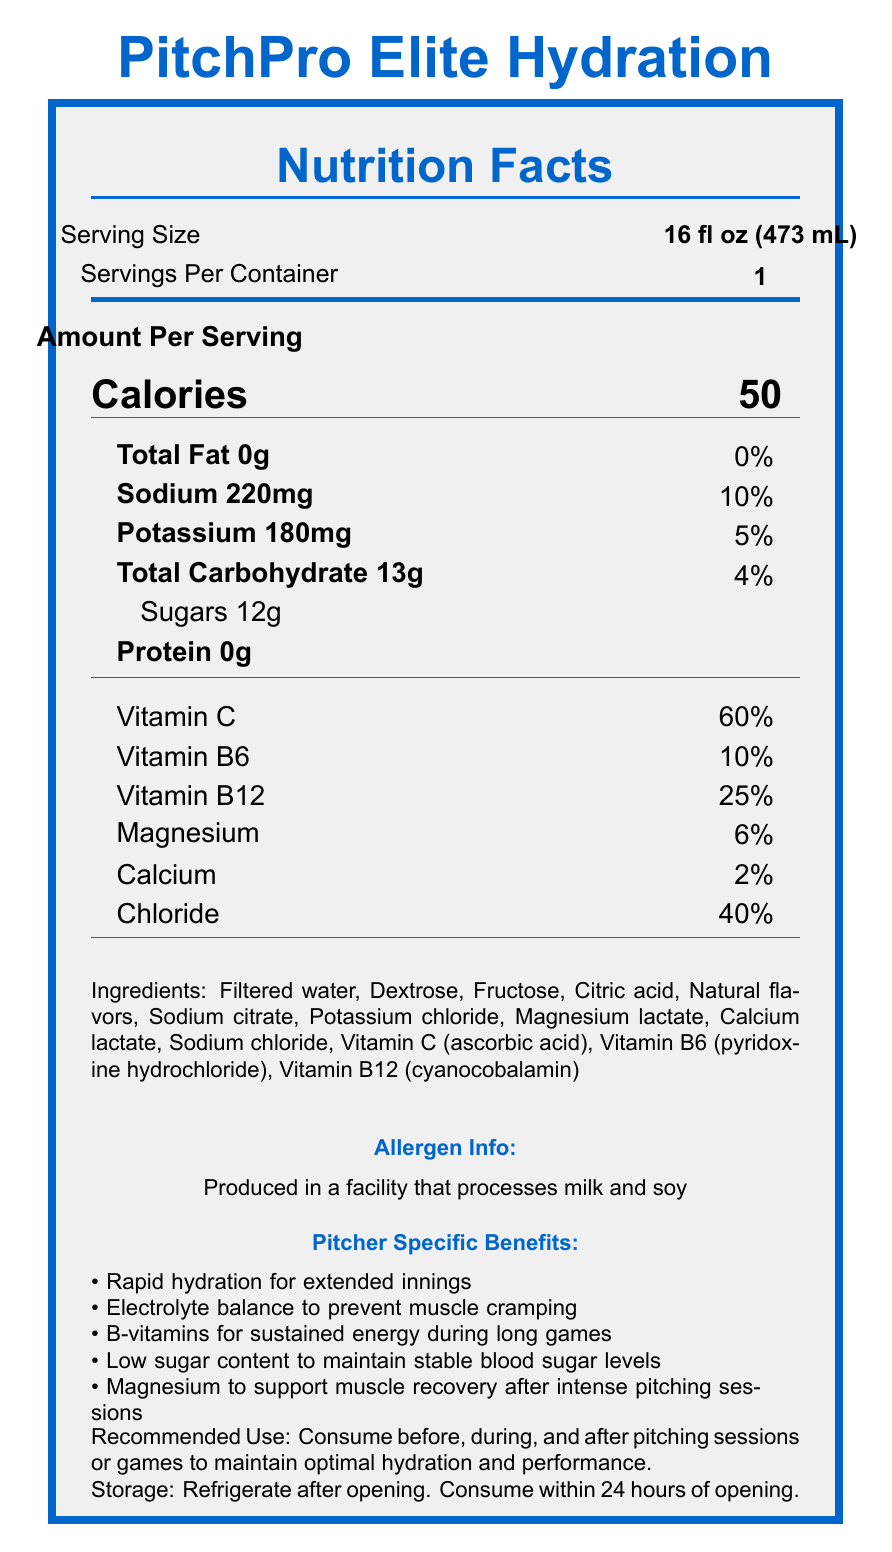what is the serving size of PitchPro Elite Hydration? The serving size is clearly mentioned under the nutrition facts header.
Answer: 16 fl oz (473 mL) how many calories are in one serving of PitchPro Elite Hydration? The number of calories per serving is displayed prominently under the "Amount Per Serving" section.
Answer: 50 how much sodium is in one serving? The sodium content is listed under the first few nutrients in the nutrition facts.
Answer: 220 mg how much potassium is in one serving? The potassium content is listed right after the sodium content in the nutrition facts.
Answer: 180 mg what vitamins are included and how much of each? The vitamins and their respective percentages are listed below the main nutrient section in the nutrition facts.
Answer: Vitamin C 60%, Vitamin B6 10%, Vitamin B12 25% What are the main ingredients in PitchPro Elite Hydration? A. Filtered water, Dextrose, Citric acid B. Filtered water, Dextrose, Fructose C. Filtered water, Sodium citrate, Potassium chloride D. Filtered water, Fructose, Vitamin C The initial ingredients listed include Filtered water, Dextrose, and Fructose.
Answer: B. Filtered water, Dextrose, Fructose Which of the following benefits is not explicitly stated for pitchers consuming this drink? 1. Improved batting performance 2. Electrolyte balance to prevent muscle cramping 3. Rapid hydration for extended innings 4. Magnesium to support muscle recovery The pitcher-specific benefits are listed and "Improved batting performance" is not one of them.
Answer: 1. Improved batting performance Does PitchPro Elite Hydration have any fat content? The nutrition facts clearly state that the total fat content is 0g.
Answer: No Is this product produced in a facility that processes any allergens? It is noted in the allergen info section that the product is produced in a facility that processes milk and soy.
Answer: Yes Summarize the main features and benefits of PitchPro Elite Hydration. This summary includes the serving size, calorie content, key nutrient and electrolyte information, vitamin content, specific benefits for pitchers, and allergen information.
Answer: PitchPro Elite Hydration is a hydration drink designed for pitchers, with a serving size of 16 fl oz and 50 calories per serving. It contains electrolytes like sodium and potassium, 12g of sugars, and essential vitamins including Vitamin C, B6, and B12. The drink is specifically formulated for rapid hydration, muscle cramp prevention, sustained energy, and muscle recovery. It does not contain fat or protein and is produced in a facility that processes milk and soy. What is the total carbohydrate content per serving? The total carbohydrate content is listed as 13g in the nutrition facts.
Answer: 13g Are there any claims about the sugar content's impact on blood sugar levels? One of the pitcher-specific benefits is "Low sugar content to maintain stable blood sugar levels."
Answer: Yes Can this drink be used by someone who is lactose intolerant? The document states that it is produced in a facility that processes milk, but it does not specify whether it contains milk directly.
Answer: Cannot be determined 